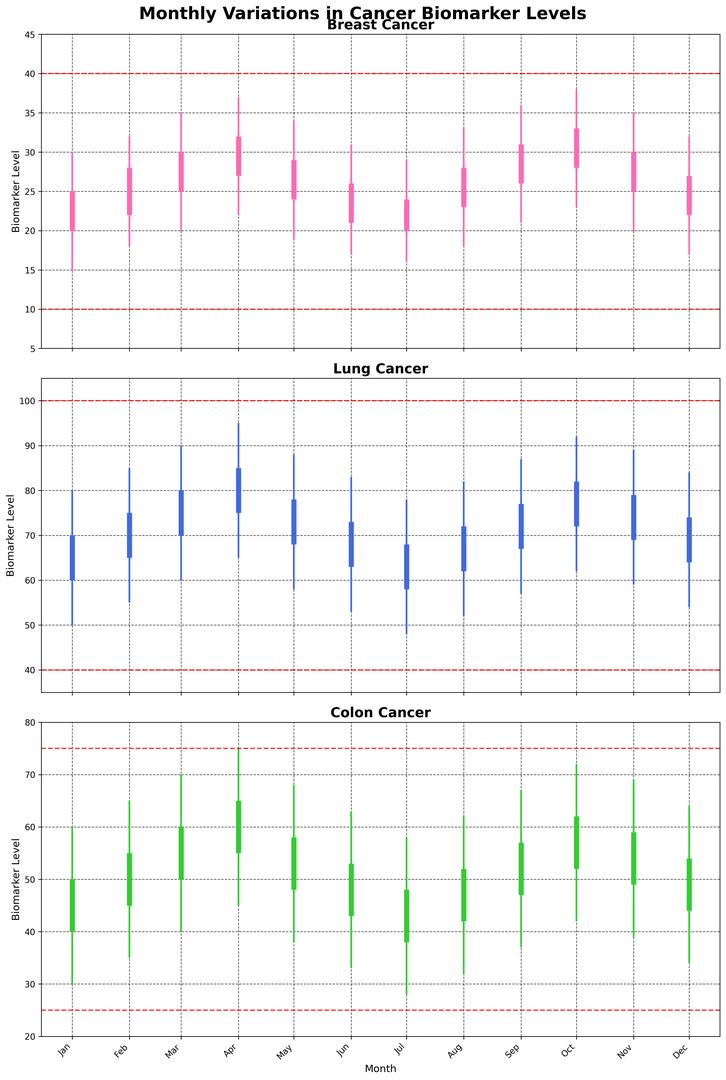How does the range of biomarker levels for Breast cancer in January compare to November? To compare the ranges, look at the candlestick's lowest and highest points for January and November in the Breast cancer plot. In January, the range is from 15 to 30, and in November, it is from 20 to 35.
Answer: Jan: 15-30; Nov: 20-35 Which cancer type shows the highest average closing biomarker level over the year? Calculate the average closing level for each cancer type by summing up their individual monthly closing levels and dividing by 12 (number of months). Breast: (25+28+30+32+29+26+24+28+31+33+30+27)/12 = 28. Lung: (70+75+80+85+78+73+68+72+77+82+79+74)/12 = 75. Colon: (50+55+60+65+58+53+48+52+57+62+59+54)/12 = 56. Lung shows the highest average closing level.
Answer: Lung What month exhibited the lowest biomarker opening level for Lung cancer, and what was the level? Look for the month with the lowest opening level in the Lung cancer plot. July shows the lowest opening level at 58.
Answer: July, 58 Did the biomarker levels for Colon cancer ever exceed the high diagnostic threshold? Examine the highpoints of the candlesticks in the Colon cancer plot and compare them to the high diagnostic threshold (75). The highest level reached is 75 in April, which equals but does not exceed the threshold.
Answer: No In which months did Breast cancer's biomarker levels drop below the low diagnostic threshold? Identify the months where the lowest points of the candlesticks for Breast cancer fall below the low diagnostic threshold (10). Since the threshold low is 10 and the lowest levels observed are 15 and above, the levels never dropped below the threshold.
Answer: None How did the biomarker highs in July compare across all three cancer types? In July, compare the highest points of the candlesticks in each plot. Breast: 29, Lung: 78, Colon: 58.
Answer: Breast: 29, Lung: 78, Colon: 58 What is the difference between the highest and lowest biomarker levels for Colon cancer in April? Calculate the difference by subtracting the lowest level from the highest level in April for Colon cancer. Highest (75) - Lowest (45) = 30.
Answer: 30 What trend can you observe in the biomarker closing levels for Breast cancer between January and December? Observe the trend in the closing levels for each month from January to December in the Breast cancer plot. The closing levels generally show an upward trend with some fluctuations.
Answer: Upward trend What is the average of the high diagnostic thresholds across all cancer types? The high diagnostic thresholds for Breast, Lung, and Colon cancers are 40, 100, and 75 respectively. (40 + 100 + 75)/3 = 71.67.
Answer: 71.67 Between which months did Lung cancer show the most significant drop in biomarker closing levels? Compare the monthly closing levels of Lung cancer and find the month-to-month differences. The largest drop is between April and May (85 to 78, a drop of 7).
Answer: April to May 